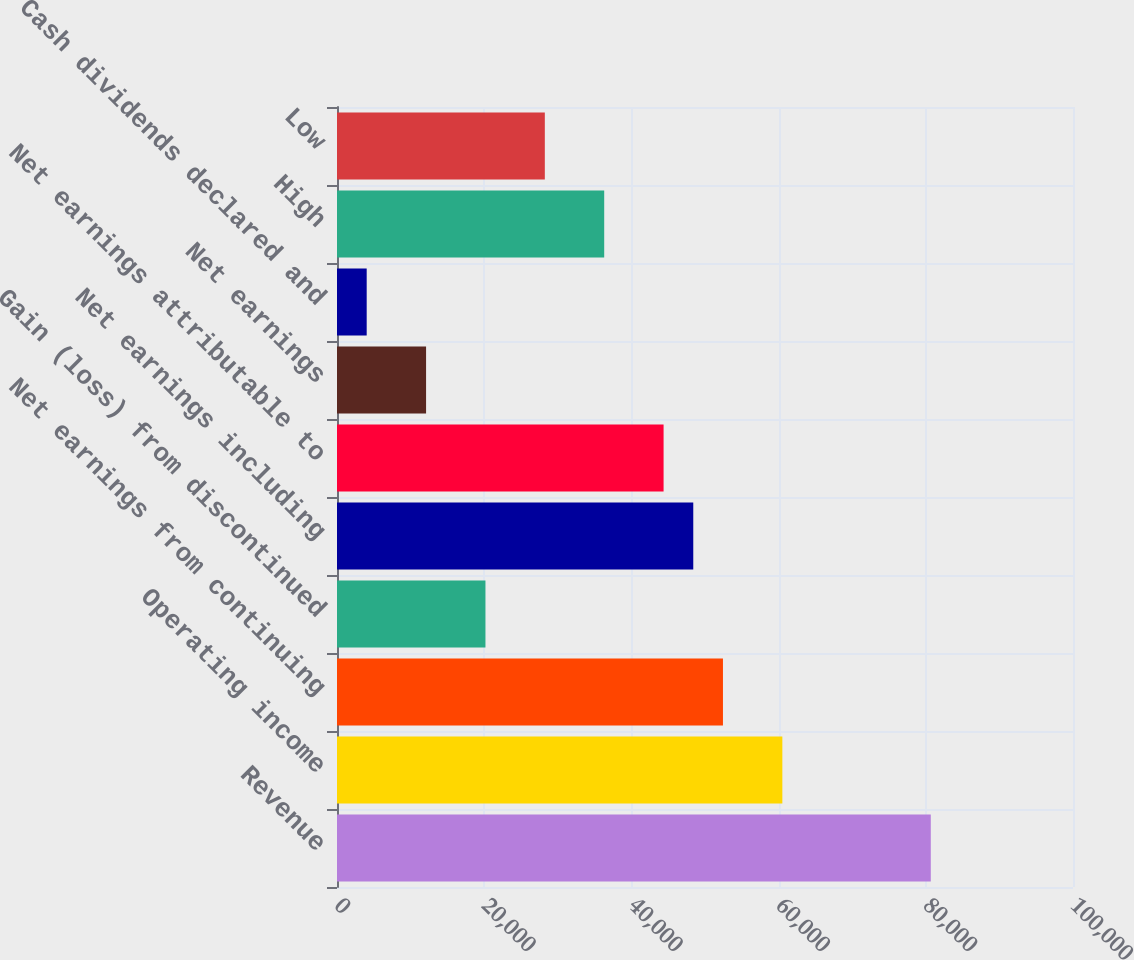Convert chart to OTSL. <chart><loc_0><loc_0><loc_500><loc_500><bar_chart><fcel>Revenue<fcel>Operating income<fcel>Net earnings from continuing<fcel>Gain (loss) from discontinued<fcel>Net earnings including<fcel>Net earnings attributable to<fcel>Net earnings<fcel>Cash dividends declared and<fcel>High<fcel>Low<nl><fcel>80677.5<fcel>60508.2<fcel>52440.6<fcel>20169.8<fcel>48406.7<fcel>44372.8<fcel>12102<fcel>4034.35<fcel>36305.2<fcel>28237.5<nl></chart> 